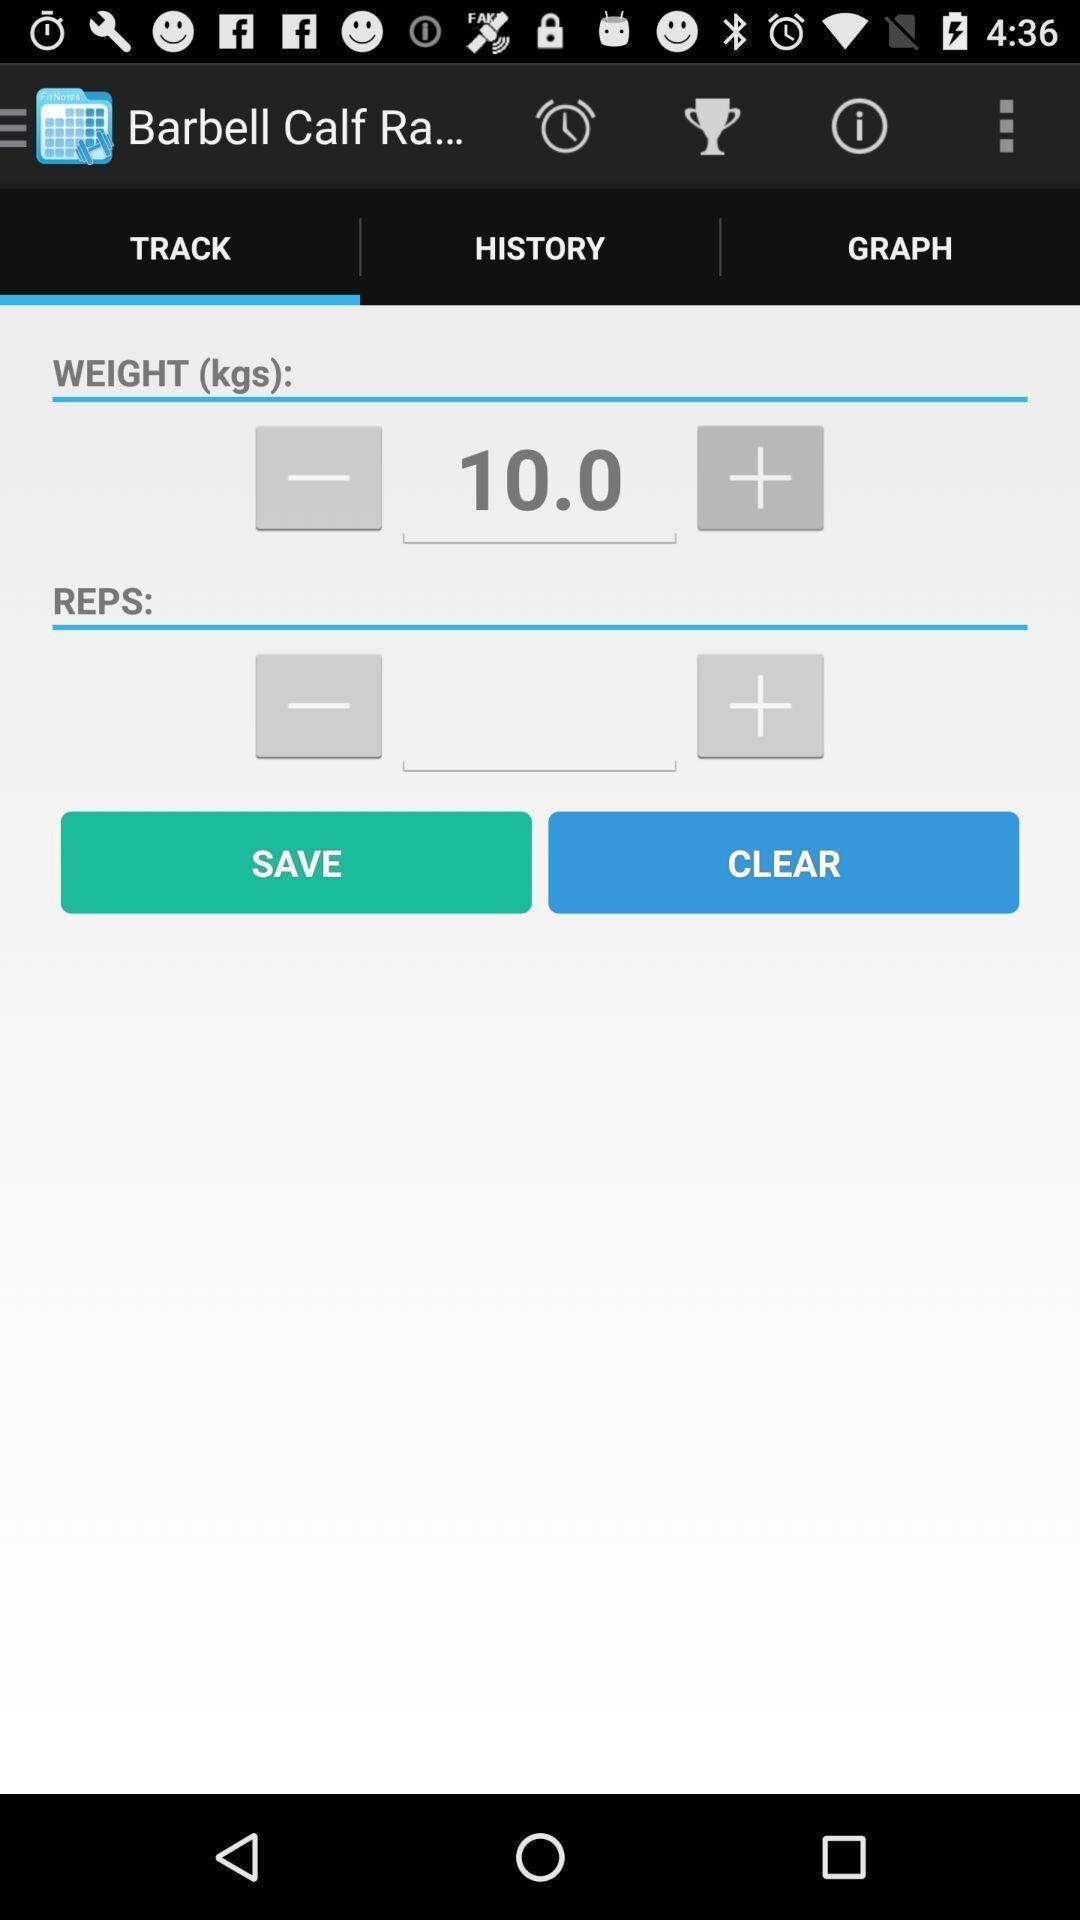What details can you identify in this image? Track page in a fitness app. 